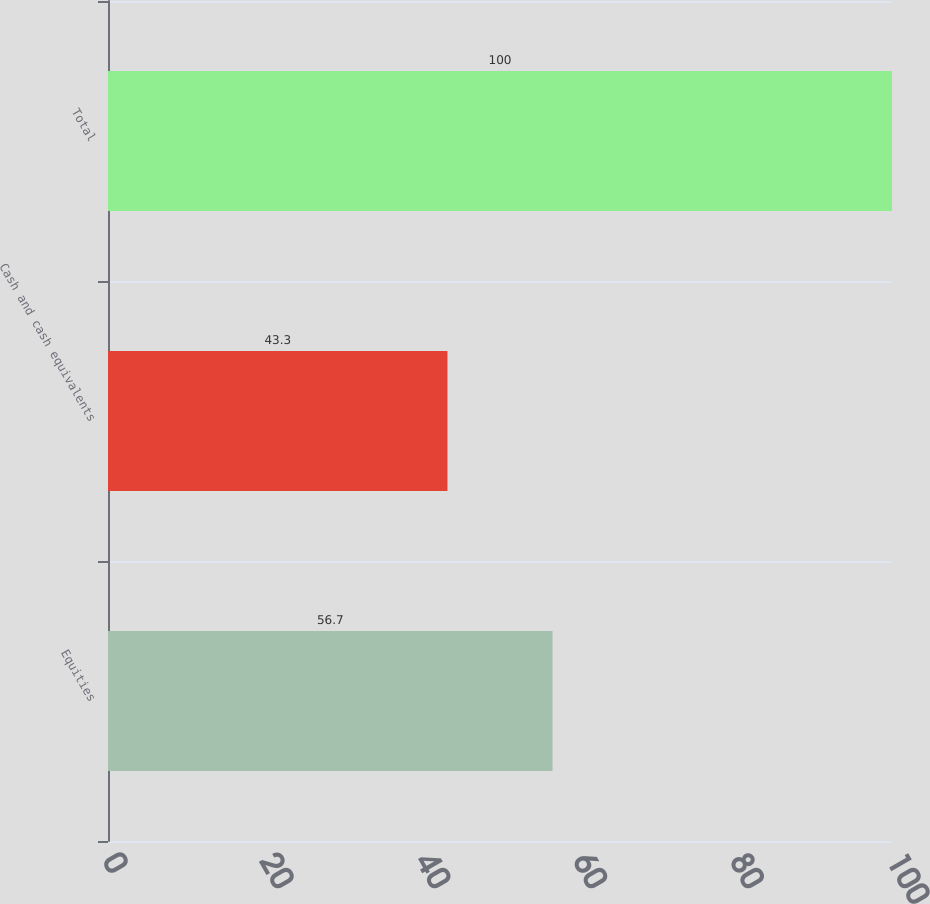<chart> <loc_0><loc_0><loc_500><loc_500><bar_chart><fcel>Equities<fcel>Cash and cash equivalents<fcel>Total<nl><fcel>56.7<fcel>43.3<fcel>100<nl></chart> 